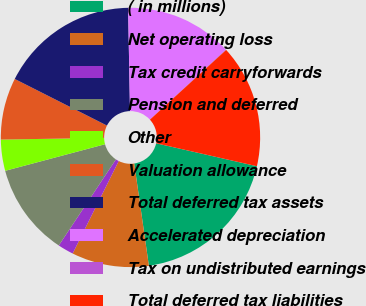<chart> <loc_0><loc_0><loc_500><loc_500><pie_chart><fcel>( in millions)<fcel>Net operating loss<fcel>Tax credit carryforwards<fcel>Pension and deferred<fcel>Other<fcel>Valuation allowance<fcel>Total deferred tax assets<fcel>Accelerated depreciation<fcel>Tax on undistributed earnings<fcel>Total deferred tax liabilities<nl><fcel>19.17%<fcel>9.62%<fcel>1.97%<fcel>11.53%<fcel>3.88%<fcel>7.71%<fcel>17.26%<fcel>13.44%<fcel>0.06%<fcel>15.35%<nl></chart> 